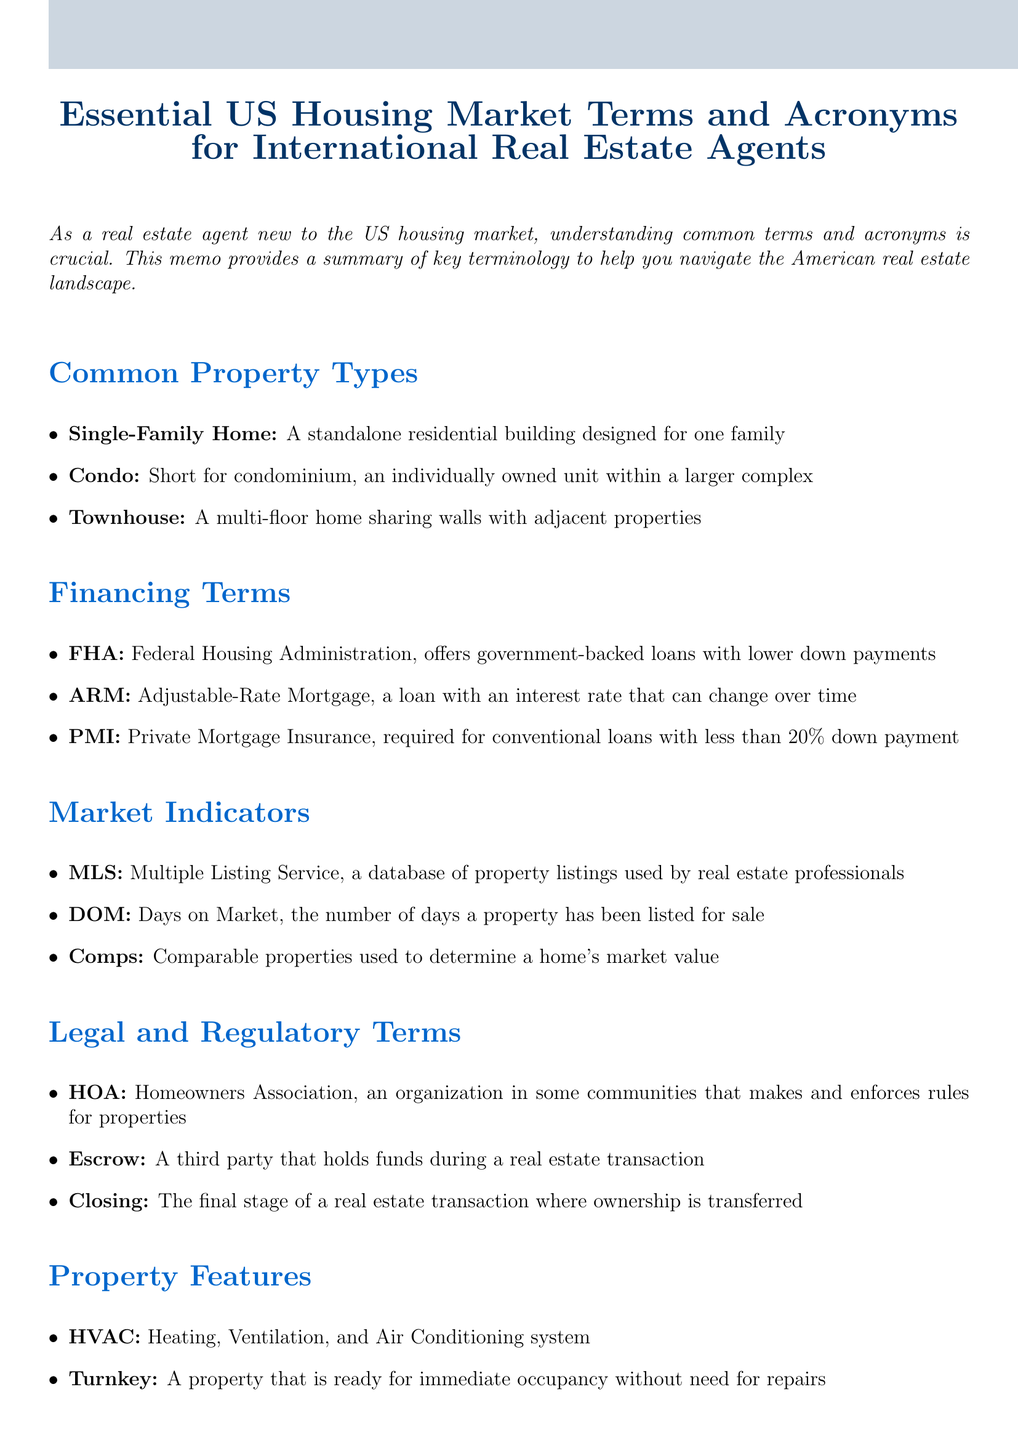What is the title of the memo? The title of the memo is indicated prominently at the beginning, summarizing the content for international real estate agents.
Answer: Essential US Housing Market Terms and Acronyms for International Real Estate Agents What does FHA stand for? FHA is mentioned in the Financing Terms section as an acronym that is explained in the document.
Answer: Federal Housing Administration How many common property types are listed? The number of property types is derived by counting the items listed in the Common Property Types section of the memo.
Answer: Three What does DOM represent in the context of the document? DOM, as defined in the Market Indicators section, represents a specific measurement related to property listings.
Answer: Days on Market What is the purpose of an HOA? HOA is defined in the Legal and Regulatory Terms section, clarifying its role in residential communities.
Answer: Makes and enforces rules for properties Which property feature indicates a home ready for immediate occupancy? The property features section includes a term that describes properties in move-in condition, pointing to its readiness for usage.
Answer: Turnkey What is the final stage of a real estate transaction called? The term for the last part of the transaction is detailed in the Legal and Regulatory Terms section.
Answer: Closing What does HVAC stand for? The document explains HVAC in the context of property features, identifying what it encompasses.
Answer: Heating, Ventilation, and Air Conditioning system 